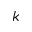<formula> <loc_0><loc_0><loc_500><loc_500>k</formula> 